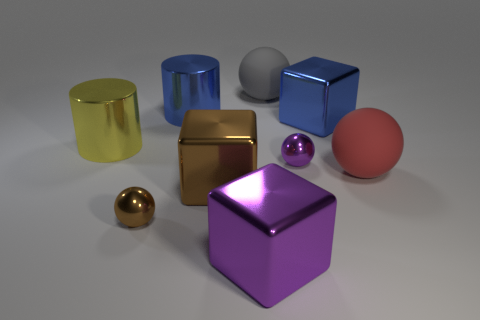Do the brown block that is in front of the yellow metallic thing and the red object in front of the gray matte thing have the same size?
Provide a succinct answer. Yes. What material is the ball that is left of the small purple sphere and in front of the big gray ball?
Provide a short and direct response. Metal. What number of other objects are the same size as the gray rubber ball?
Provide a short and direct response. 6. There is a cylinder that is on the left side of the brown metallic ball; what material is it?
Give a very brief answer. Metal. Is the big gray matte thing the same shape as the big purple object?
Your answer should be compact. No. How many other objects are the same shape as the red thing?
Your answer should be compact. 3. The big metal block on the right side of the small purple metal sphere is what color?
Keep it short and to the point. Blue. Do the gray matte object and the red object have the same size?
Make the answer very short. Yes. What material is the small thing that is on the right side of the cube in front of the small brown object made of?
Offer a very short reply. Metal. Are there any other things that have the same material as the gray object?
Make the answer very short. Yes. 